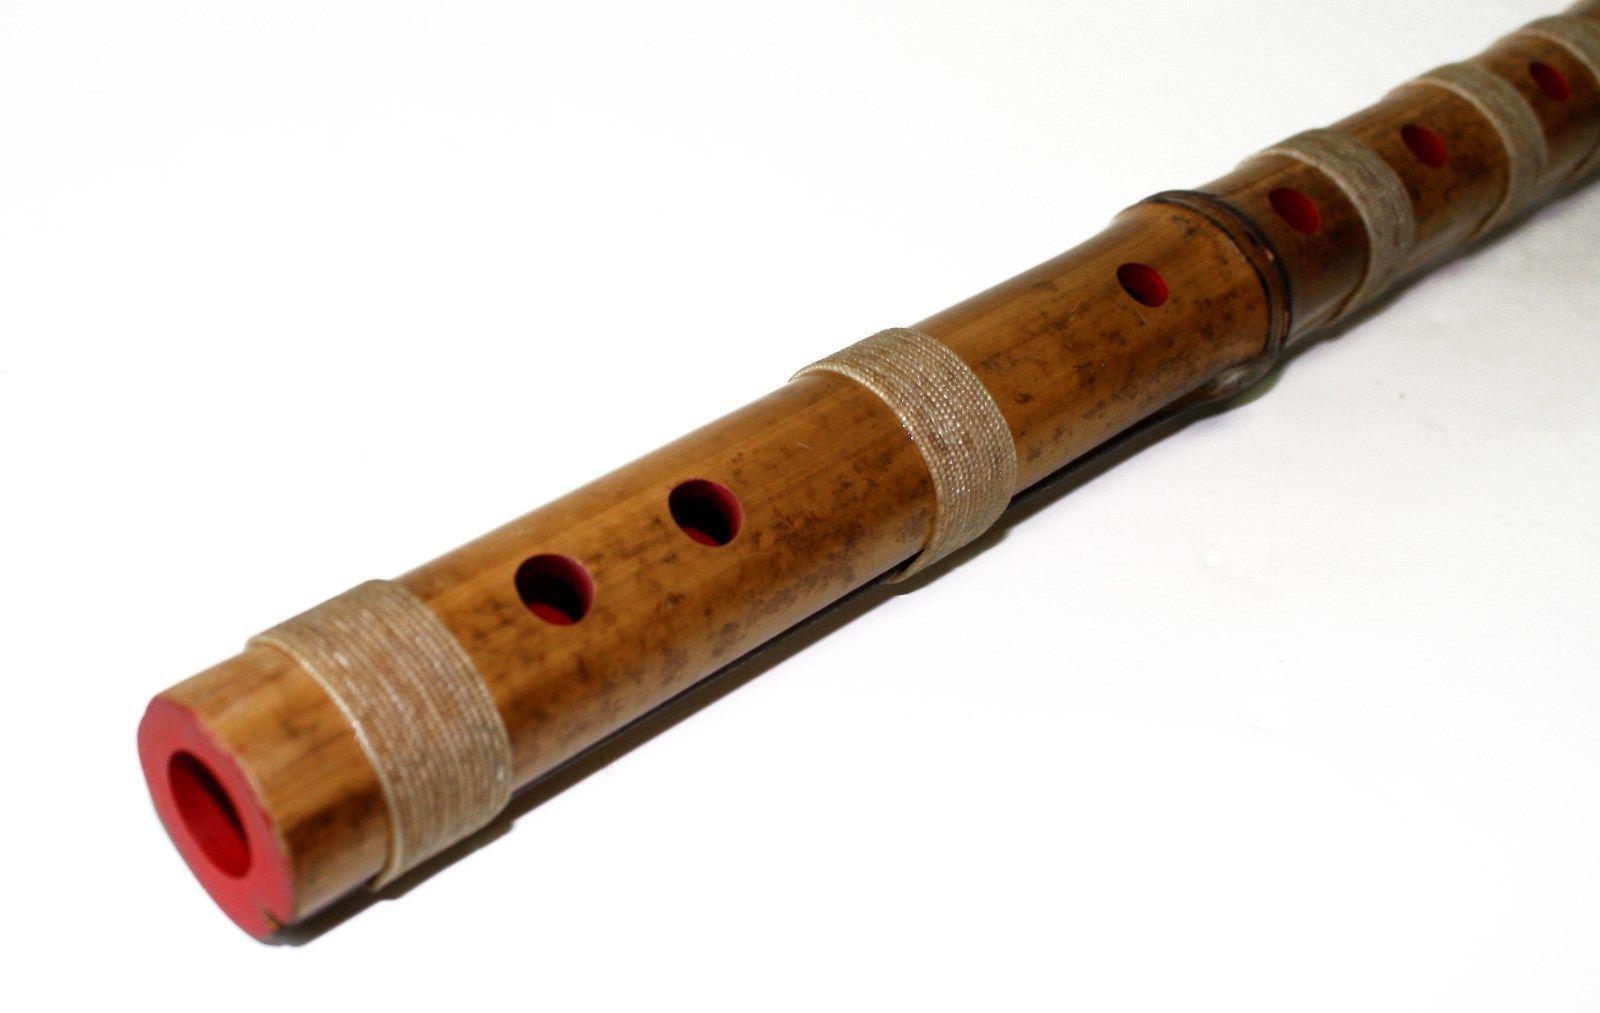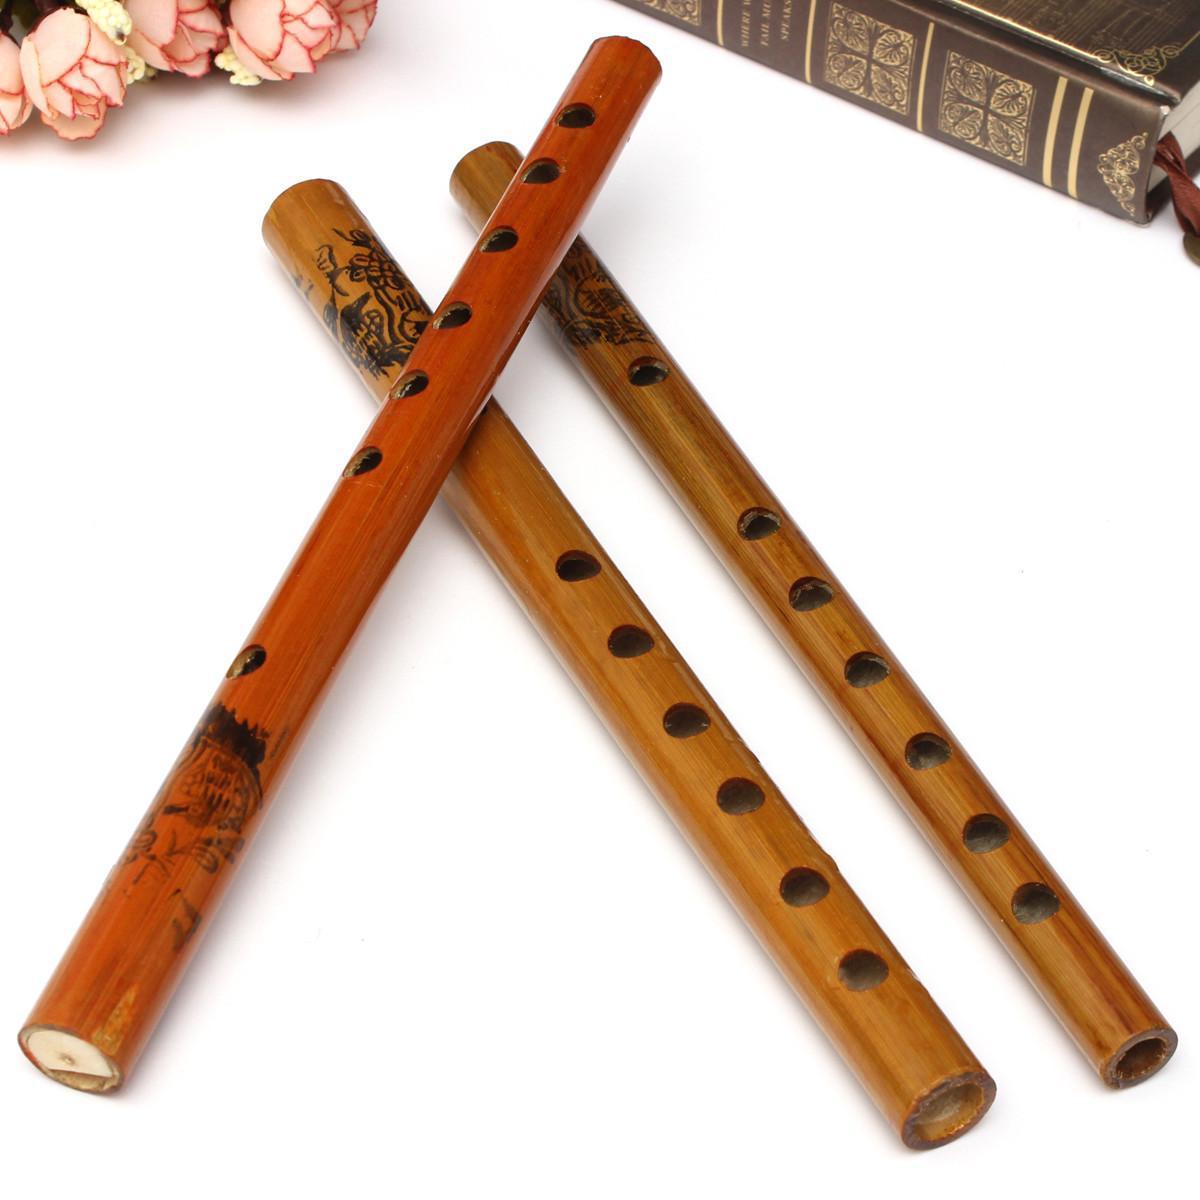The first image is the image on the left, the second image is the image on the right. Examine the images to the left and right. Is the description "Three or fewer flutes are visible." accurate? Answer yes or no. No. The first image is the image on the left, the second image is the image on the right. Analyze the images presented: Is the assertion "There appears to be four flutes." valid? Answer yes or no. Yes. 